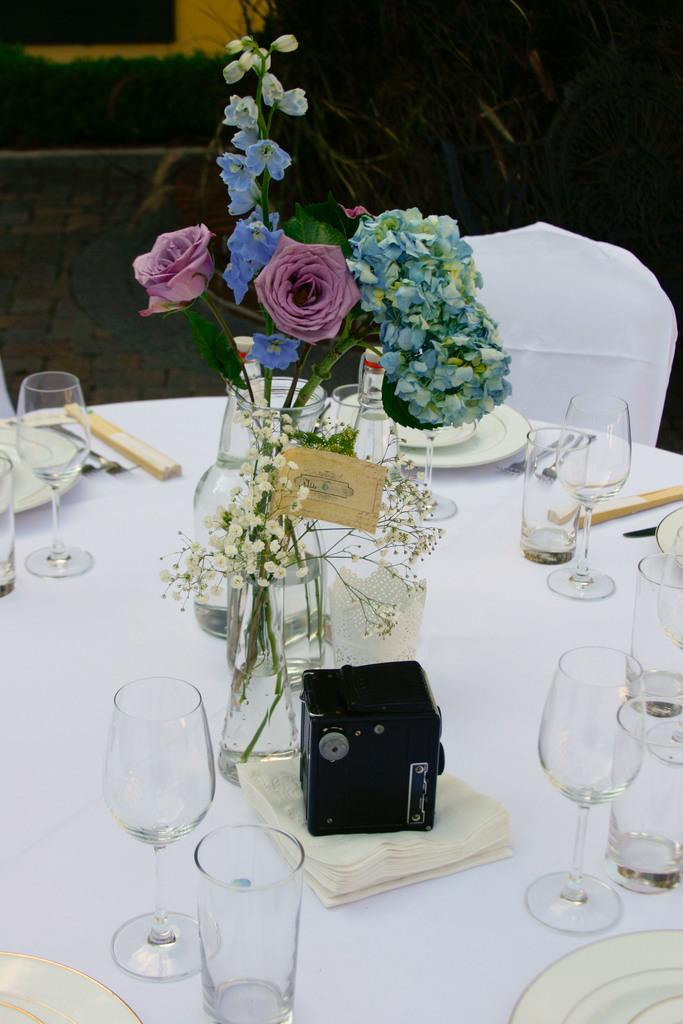What is on the table in the image? There are flowers with a vase, glasses, tissue papers, and plates on the table. What else can be seen in the image besides the table? There are chairs visible and plants in the image. What might be used for cleaning or wiping in the image? Tissue papers are present on the table for cleaning or wiping. Where is the dad sitting in the image? There is no dad present in the image. Can you see a dock in the image? There is no dock present in the image. 